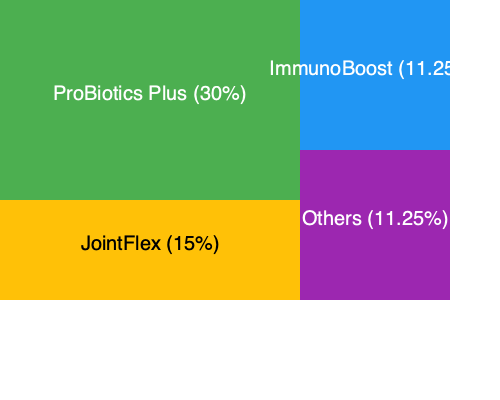Based on the treemap chart showing market share of veterinary supplements, what is the ratio of ProBiotics Plus's market share to the combined market share of JointFlex and ImmunoBoost? To solve this problem, we need to follow these steps:

1. Identify the market share percentages:
   - ProBiotics Plus: 30%
   - JointFlex: 15%
   - ImmunoBoost: 11.25%

2. Calculate the combined market share of JointFlex and ImmunoBoost:
   $15\% + 11.25\% = 26.25\%$

3. Set up the ratio of ProBiotics Plus to the combined share:
   $\frac{\text{ProBiotics Plus}}{\text{JointFlex + ImmunoBoost}} = \frac{30\%}{26.25\%}$

4. Simplify the ratio:
   $\frac{30}{26.25} = \frac{120}{105} = \frac{24}{21} = \frac{8}{7}$

Therefore, the ratio of ProBiotics Plus's market share to the combined market share of JointFlex and ImmunoBoost is $8:7$ or $8/7$.
Answer: $8:7$ 